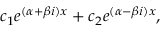<formula> <loc_0><loc_0><loc_500><loc_500>c _ { 1 } e ^ { ( \alpha + \beta i ) x } + c _ { 2 } e ^ { ( \alpha - \beta i ) x } ,</formula> 